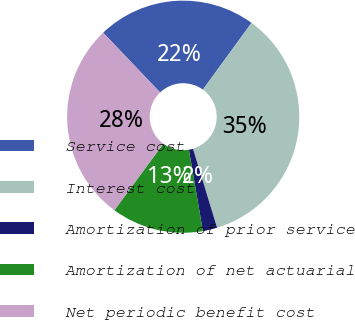<chart> <loc_0><loc_0><loc_500><loc_500><pie_chart><fcel>Service cost<fcel>Interest cost<fcel>Amortization of prior service<fcel>Amortization of net actuarial<fcel>Net periodic benefit cost<nl><fcel>22.13%<fcel>35.27%<fcel>2.0%<fcel>12.81%<fcel>27.79%<nl></chart> 